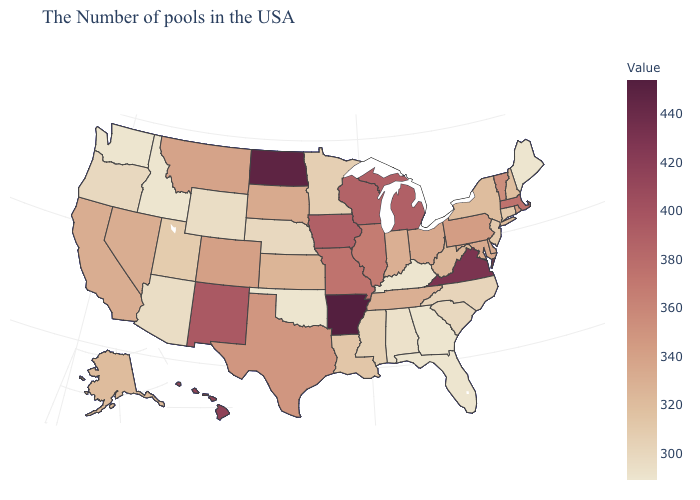Among the states that border Maine , which have the highest value?
Short answer required. New Hampshire. Among the states that border Wisconsin , which have the lowest value?
Short answer required. Minnesota. Does the map have missing data?
Keep it brief. No. Among the states that border Iowa , does Illinois have the lowest value?
Keep it brief. No. 